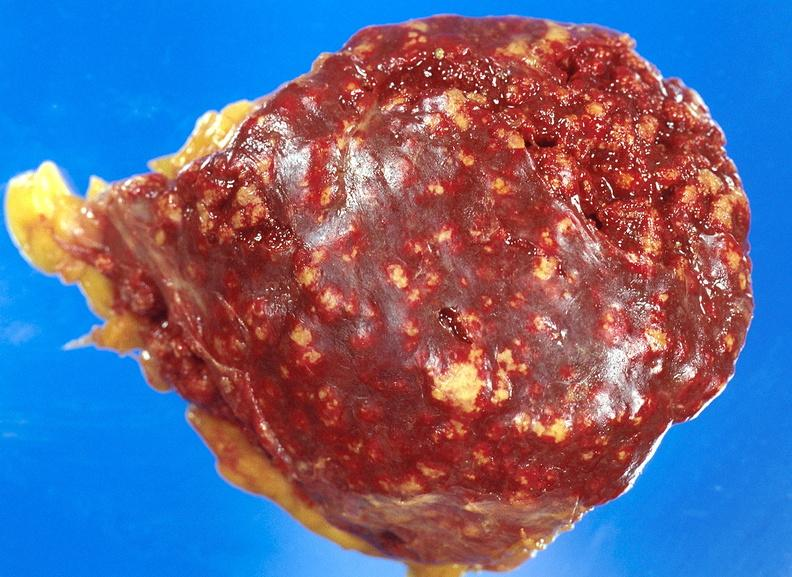s sacrococcygeal teratoma present?
Answer the question using a single word or phrase. No 